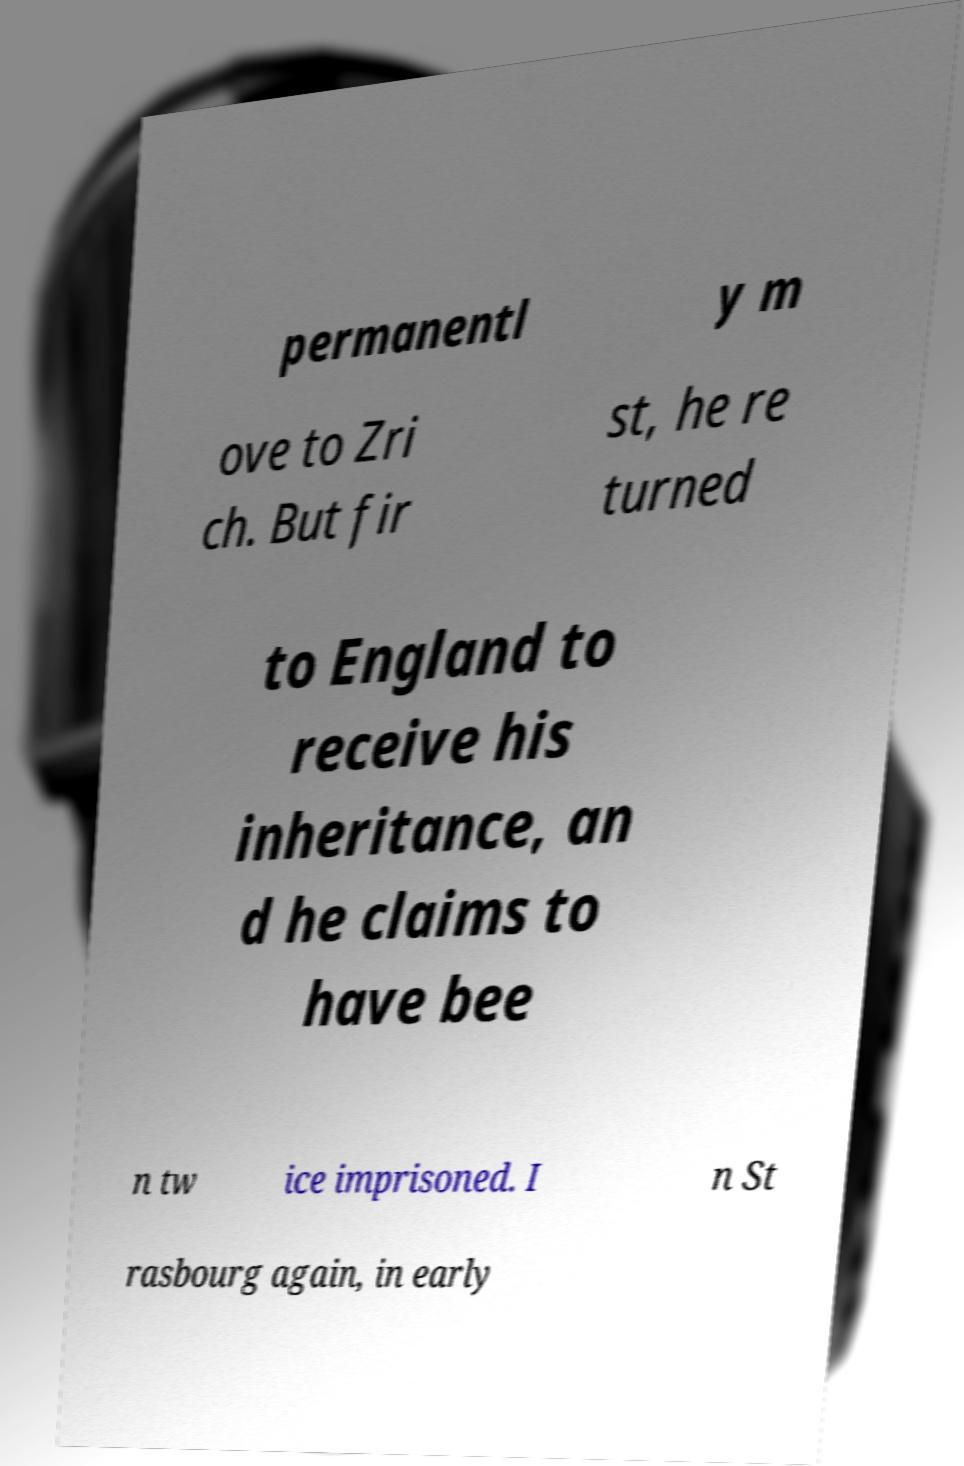For documentation purposes, I need the text within this image transcribed. Could you provide that? permanentl y m ove to Zri ch. But fir st, he re turned to England to receive his inheritance, an d he claims to have bee n tw ice imprisoned. I n St rasbourg again, in early 